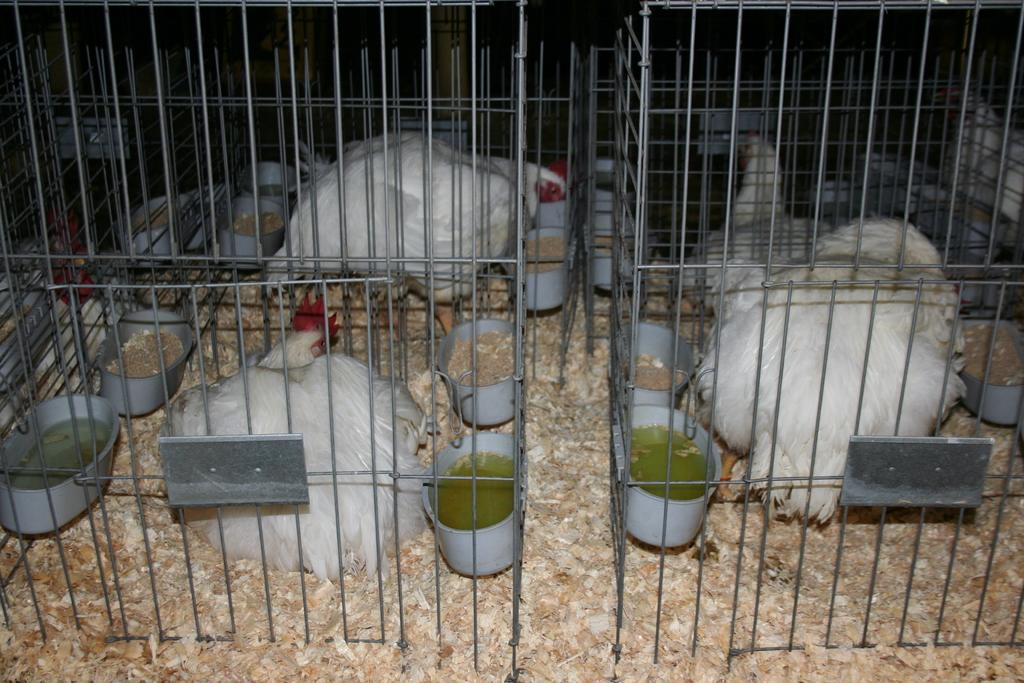What type of animals are in the cage in the image? There are white color hens in a cage in the image. Where are the hens located in the image? The hens are in the middle of the image. What can be seen in the image that might be used to feed the hens? There are food containers in the image. What can be seen in the image that might be used to provide water for the hens? There are water containers in the image. What type of toothbrush is being used to clean the hens in the image? There is no toothbrush present in the image, and the hens are not being cleaned. 